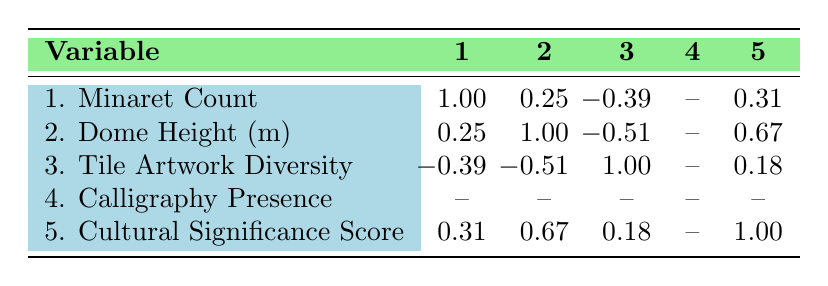What is the cultural significance score of the Hagia Sophia? The table shows that the cultural significance score for Hagia Sophia is listed under the "Cultural Significance Score" column, which is 9.
Answer: 9 What is the tile artwork diversity of the Blue Mosque? The table reveals that the Blue Mosque has a tile artwork diversity score of 10 as indicated in the corresponding row.
Answer: 10 Is there a correlation between the minaret count and cultural significance score? The correlation coefficient between minaret count and cultural significance score is 0.31, indicating a weak positive correlation.
Answer: Yes Which site has the highest dome height? By comparing the "Dome Height (m)" values, Hagia Sophia has the highest dome height at 55 meters.
Answer: Hagia Sophia What is the average dome height of the sites listed? To find the average, add up the dome heights: (55 + 35 + 53 + 43 + 24) = 210. There are 5 sites, so the average is 210/5 = 42.
Answer: 42 Do any of the sites have both a high minaret count and a high cultural significance score? Examining the minaret counts and cultural significance scores reveals that the Blue Mosque has 6 minarets and a cultural significance score of 9, showing this combination exists.
Answer: Yes What is the difference in cultural significance scores between Topkapi Palace and Rustem Pasha Mosque? The cultural significance score for Topkapi Palace is 10 and for Rustem Pasha Mosque is 7. The difference is 10 - 7 = 3.
Answer: 3 Is tile artwork diversity positively correlated with dome height? The correlation coefficient between tile artwork diversity and dome height is -0.51, indicating a moderate negative correlation, meaning as one increases, the other tends to decrease.
Answer: No Which site has the lowest minaret count? By checking the "Minaret Count" column, Rustem Pasha Mosque has the lowest count with 1 minaret.
Answer: Rustem Pasha Mosque 